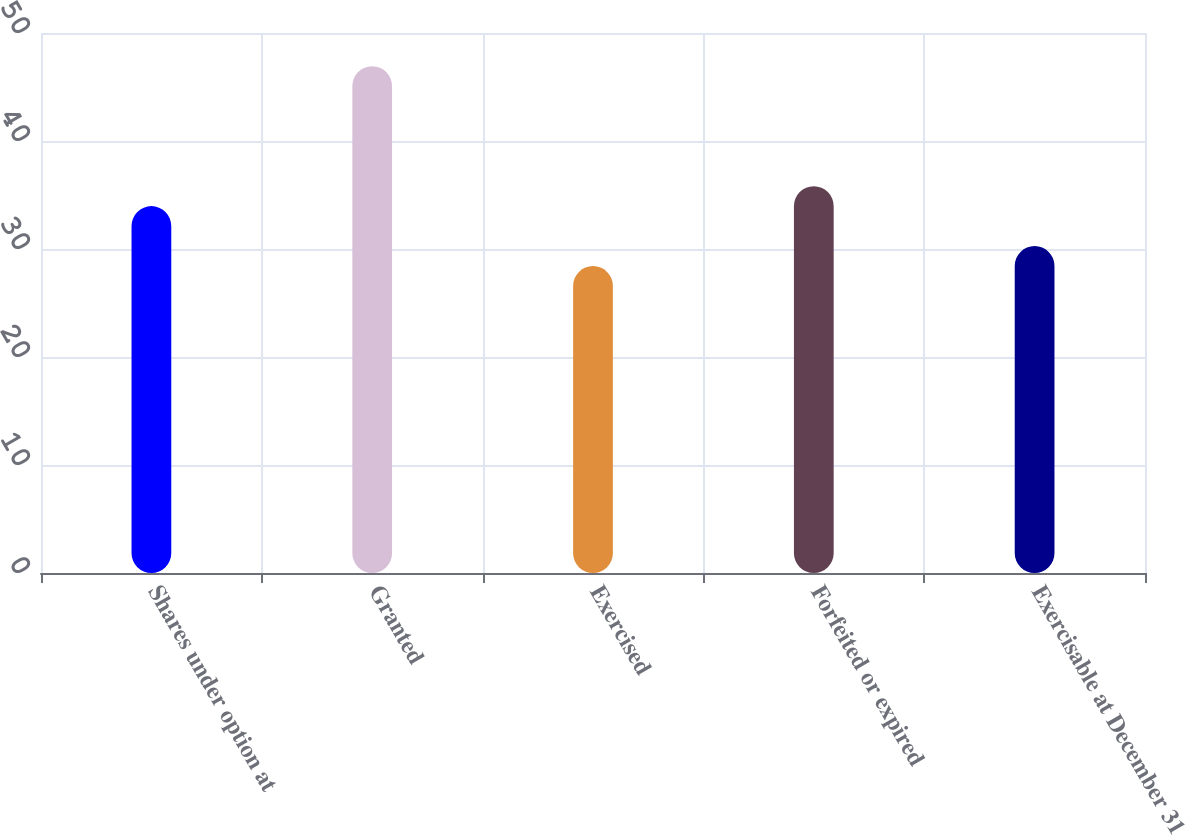Convert chart. <chart><loc_0><loc_0><loc_500><loc_500><bar_chart><fcel>Shares under option at<fcel>Granted<fcel>Exercised<fcel>Forfeited or expired<fcel>Exercisable at December 31<nl><fcel>33.97<fcel>46.92<fcel>28.42<fcel>35.82<fcel>30.27<nl></chart> 